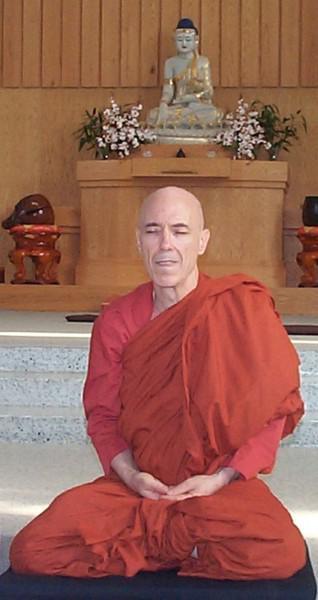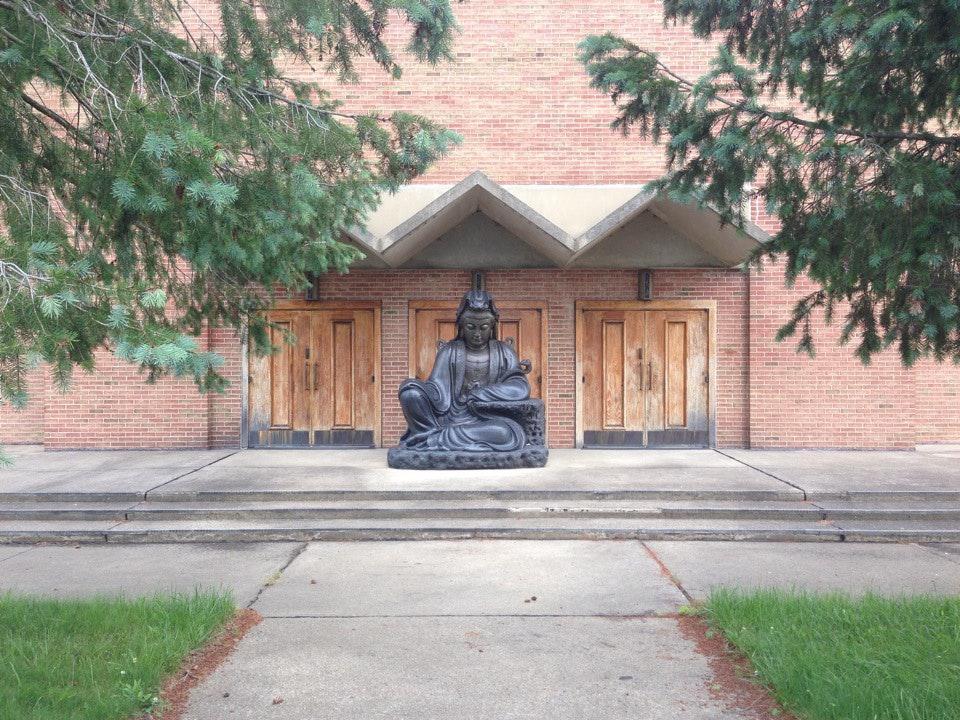The first image is the image on the left, the second image is the image on the right. For the images shown, is this caption "At least one image shows a person with a shaved head wearing a solid-colored robe." true? Answer yes or no. Yes. The first image is the image on the left, the second image is the image on the right. For the images displayed, is the sentence "At least one person is posing while wearing a robe." factually correct? Answer yes or no. Yes. 